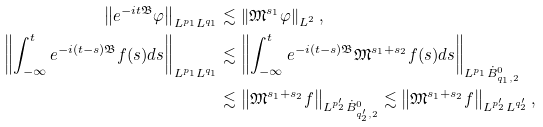Convert formula to latex. <formula><loc_0><loc_0><loc_500><loc_500>\left \| e ^ { - i t \mathfrak { B } } \varphi \right \| _ { L ^ { p _ { 1 } } L ^ { q _ { 1 } } } & \lesssim \left \| \mathfrak { M } ^ { s _ { 1 } } \varphi \right \| _ { L ^ { 2 } } , \\ \left \| \int _ { - \infty } ^ { t } e ^ { - i ( t - s ) \mathfrak { B } } f ( s ) d s \right \| _ { L ^ { p _ { 1 } } L ^ { q _ { 1 } } } & \lesssim \left \| \int _ { - \infty } ^ { t } e ^ { - i ( t - s ) \mathfrak { B } } \mathfrak { M } ^ { s _ { 1 } + s _ { 2 } } f ( s ) d s \right \| _ { L ^ { p _ { 1 } } \dot { B } _ { q _ { 1 } , 2 } ^ { 0 } } \\ & \lesssim \left \| \mathfrak { M } ^ { s _ { 1 } + s _ { 2 } } f \right \| _ { L ^ { p _ { 2 } ^ { \prime } } \dot { B } _ { q _ { 2 } ^ { \prime } , 2 } ^ { 0 } } \lesssim \left \| \mathfrak { M } ^ { s _ { 1 } + s _ { 2 } } f \right \| _ { L ^ { p _ { 2 } ^ { \prime } } L ^ { q _ { 2 } ^ { \prime } } } ,</formula> 